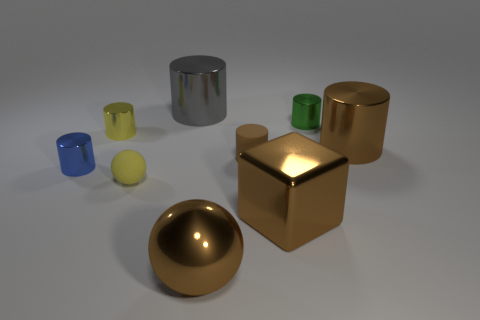Subtract all blue shiny cylinders. How many cylinders are left? 5 Subtract all gray cylinders. How many cylinders are left? 5 Subtract all purple cylinders. Subtract all purple balls. How many cylinders are left? 6 Add 1 red cylinders. How many objects exist? 10 Subtract all cylinders. How many objects are left? 3 Subtract 0 blue balls. How many objects are left? 9 Subtract all large red metal things. Subtract all tiny rubber balls. How many objects are left? 8 Add 8 blue things. How many blue things are left? 9 Add 4 big blue metallic cylinders. How many big blue metallic cylinders exist? 4 